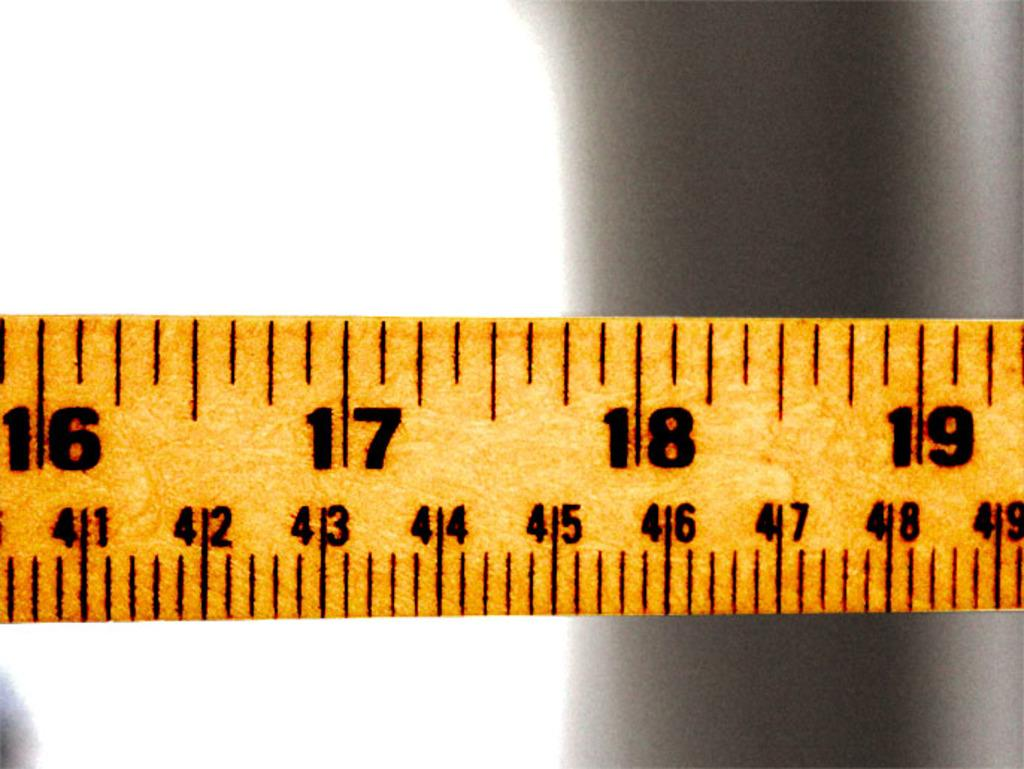<image>
Render a clear and concise summary of the photo. The inch measurements that are visible are 16,17,18, and 19. 